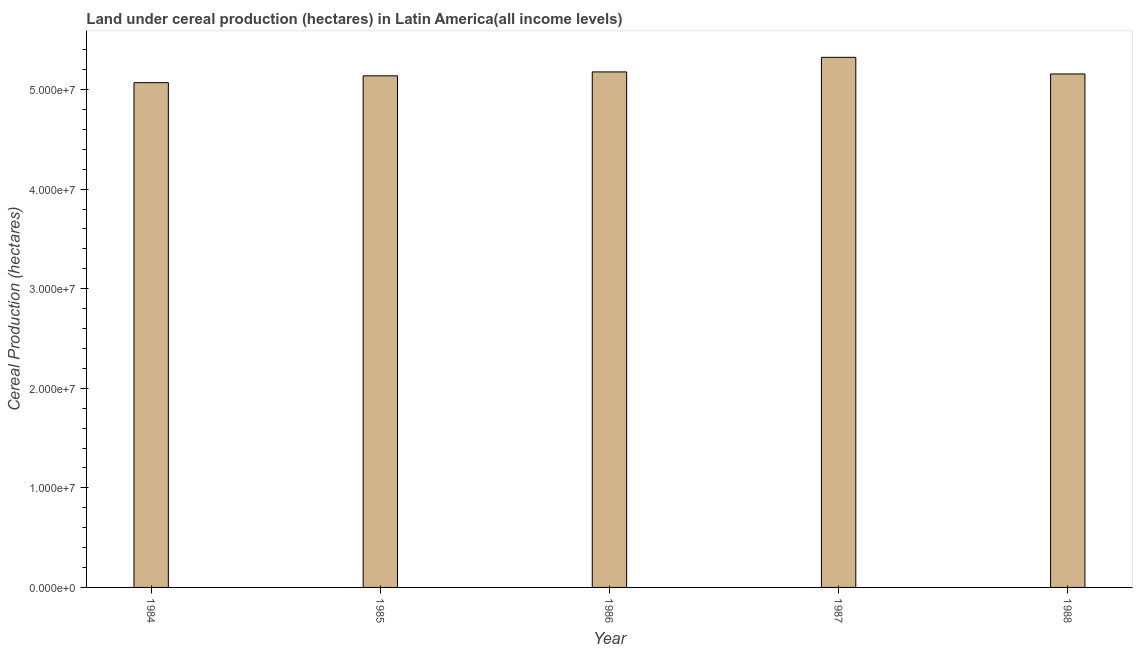What is the title of the graph?
Ensure brevity in your answer.  Land under cereal production (hectares) in Latin America(all income levels). What is the label or title of the X-axis?
Your answer should be very brief. Year. What is the label or title of the Y-axis?
Offer a terse response. Cereal Production (hectares). What is the land under cereal production in 1987?
Your response must be concise. 5.32e+07. Across all years, what is the maximum land under cereal production?
Your answer should be compact. 5.32e+07. Across all years, what is the minimum land under cereal production?
Provide a succinct answer. 5.07e+07. In which year was the land under cereal production maximum?
Keep it short and to the point. 1987. What is the sum of the land under cereal production?
Your answer should be compact. 2.59e+08. What is the difference between the land under cereal production in 1986 and 1987?
Ensure brevity in your answer.  -1.46e+06. What is the average land under cereal production per year?
Your response must be concise. 5.17e+07. What is the median land under cereal production?
Keep it short and to the point. 5.16e+07. Is the land under cereal production in 1984 less than that in 1985?
Give a very brief answer. Yes. Is the difference between the land under cereal production in 1985 and 1986 greater than the difference between any two years?
Your answer should be compact. No. What is the difference between the highest and the second highest land under cereal production?
Provide a succinct answer. 1.46e+06. Is the sum of the land under cereal production in 1985 and 1988 greater than the maximum land under cereal production across all years?
Offer a very short reply. Yes. What is the difference between the highest and the lowest land under cereal production?
Offer a very short reply. 2.54e+06. How many years are there in the graph?
Ensure brevity in your answer.  5. What is the difference between two consecutive major ticks on the Y-axis?
Your answer should be very brief. 1.00e+07. What is the Cereal Production (hectares) in 1984?
Make the answer very short. 5.07e+07. What is the Cereal Production (hectares) of 1985?
Ensure brevity in your answer.  5.14e+07. What is the Cereal Production (hectares) of 1986?
Offer a very short reply. 5.18e+07. What is the Cereal Production (hectares) in 1987?
Ensure brevity in your answer.  5.32e+07. What is the Cereal Production (hectares) of 1988?
Your answer should be very brief. 5.16e+07. What is the difference between the Cereal Production (hectares) in 1984 and 1985?
Offer a terse response. -6.86e+05. What is the difference between the Cereal Production (hectares) in 1984 and 1986?
Your answer should be compact. -1.08e+06. What is the difference between the Cereal Production (hectares) in 1984 and 1987?
Your answer should be compact. -2.54e+06. What is the difference between the Cereal Production (hectares) in 1984 and 1988?
Offer a very short reply. -8.74e+05. What is the difference between the Cereal Production (hectares) in 1985 and 1986?
Keep it short and to the point. -3.94e+05. What is the difference between the Cereal Production (hectares) in 1985 and 1987?
Your answer should be compact. -1.86e+06. What is the difference between the Cereal Production (hectares) in 1985 and 1988?
Keep it short and to the point. -1.88e+05. What is the difference between the Cereal Production (hectares) in 1986 and 1987?
Make the answer very short. -1.46e+06. What is the difference between the Cereal Production (hectares) in 1986 and 1988?
Provide a short and direct response. 2.06e+05. What is the difference between the Cereal Production (hectares) in 1987 and 1988?
Keep it short and to the point. 1.67e+06. What is the ratio of the Cereal Production (hectares) in 1984 to that in 1985?
Your response must be concise. 0.99. What is the ratio of the Cereal Production (hectares) in 1984 to that in 1986?
Keep it short and to the point. 0.98. What is the ratio of the Cereal Production (hectares) in 1985 to that in 1986?
Provide a short and direct response. 0.99. What is the ratio of the Cereal Production (hectares) in 1985 to that in 1987?
Your answer should be very brief. 0.96. What is the ratio of the Cereal Production (hectares) in 1985 to that in 1988?
Make the answer very short. 1. What is the ratio of the Cereal Production (hectares) in 1986 to that in 1987?
Make the answer very short. 0.97. What is the ratio of the Cereal Production (hectares) in 1986 to that in 1988?
Offer a terse response. 1. What is the ratio of the Cereal Production (hectares) in 1987 to that in 1988?
Your answer should be very brief. 1.03. 